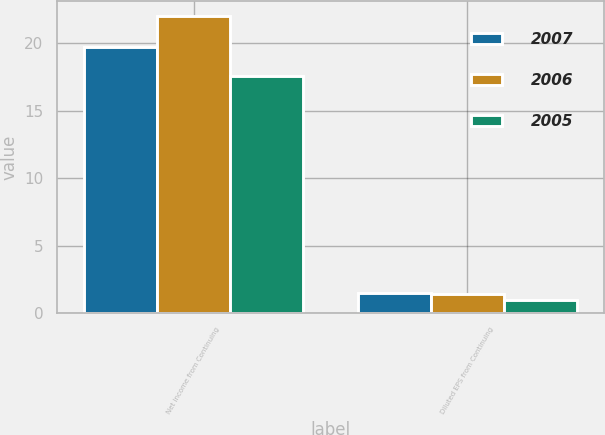Convert chart. <chart><loc_0><loc_0><loc_500><loc_500><stacked_bar_chart><ecel><fcel>Net income from Continuing<fcel>Diluted EPS from Continuing<nl><fcel>2007<fcel>19.7<fcel>1.51<nl><fcel>2006<fcel>22<fcel>1.39<nl><fcel>2005<fcel>17.6<fcel>0.98<nl></chart> 